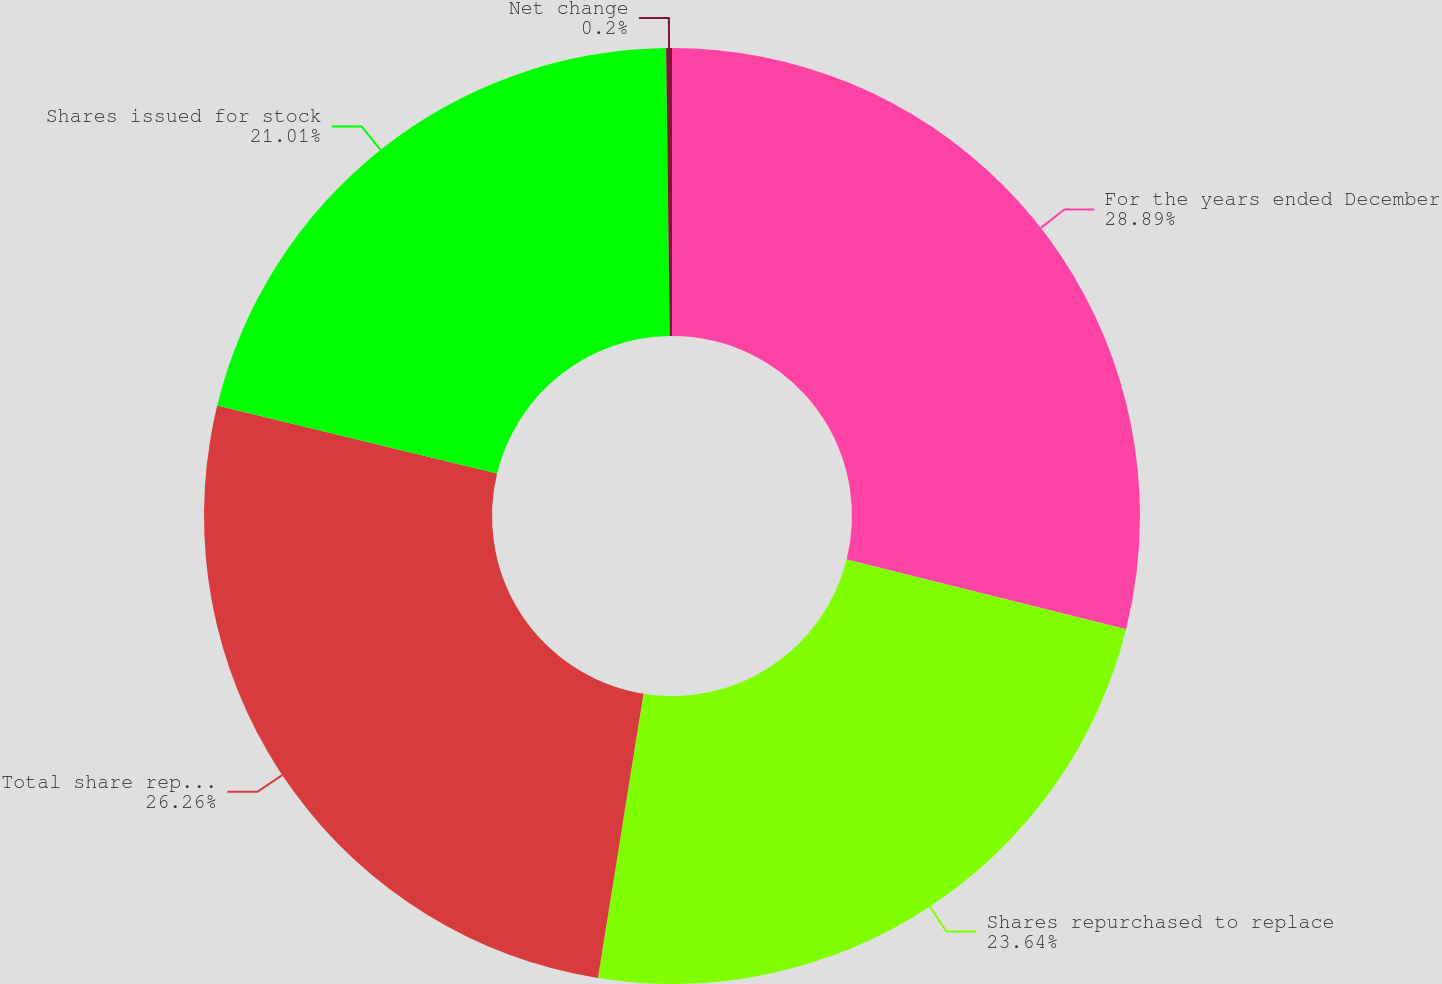<chart> <loc_0><loc_0><loc_500><loc_500><pie_chart><fcel>For the years ended December<fcel>Shares repurchased to replace<fcel>Total share repurchases<fcel>Shares issued for stock<fcel>Net change<nl><fcel>28.89%<fcel>23.64%<fcel>26.26%<fcel>21.01%<fcel>0.2%<nl></chart> 